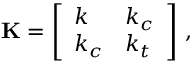<formula> <loc_0><loc_0><loc_500><loc_500>K = \left [ \begin{array} { l l } { k } & { k _ { c } } \\ { k _ { c } } & { k _ { t } } \end{array} \right ] \, ,</formula> 